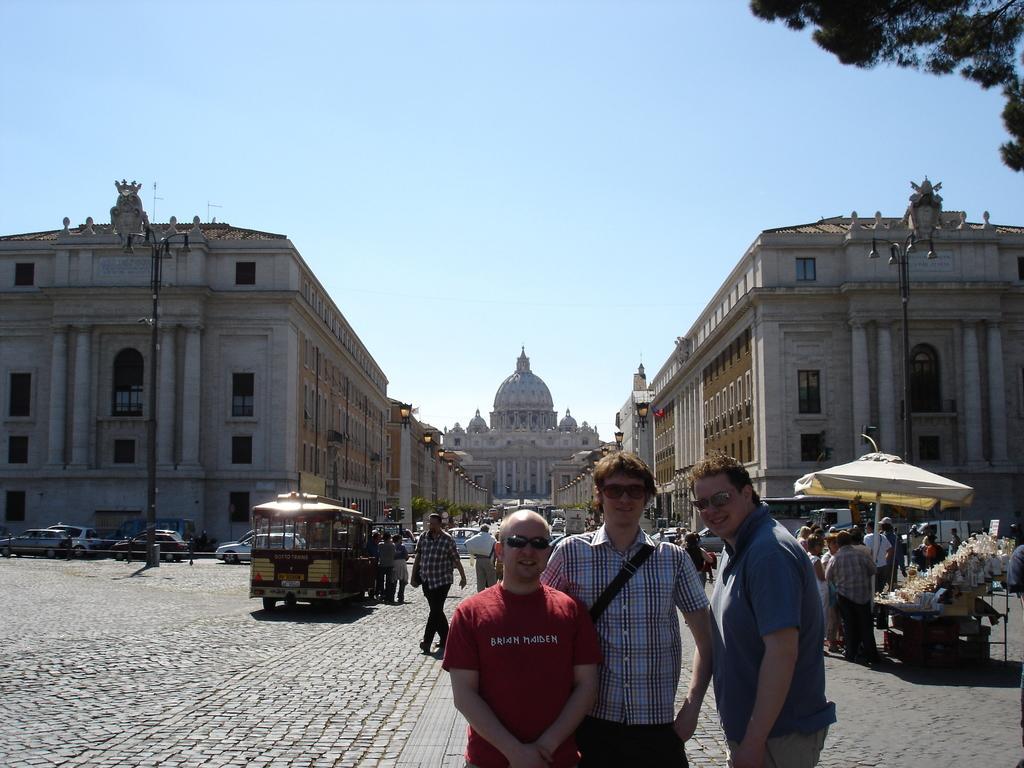Can you describe this image briefly? There are three persons posing to a camera. This is road and there are vehicles. Here we can see few persons, umbrella, plants, poles, and buildings. In the background there is sky. 